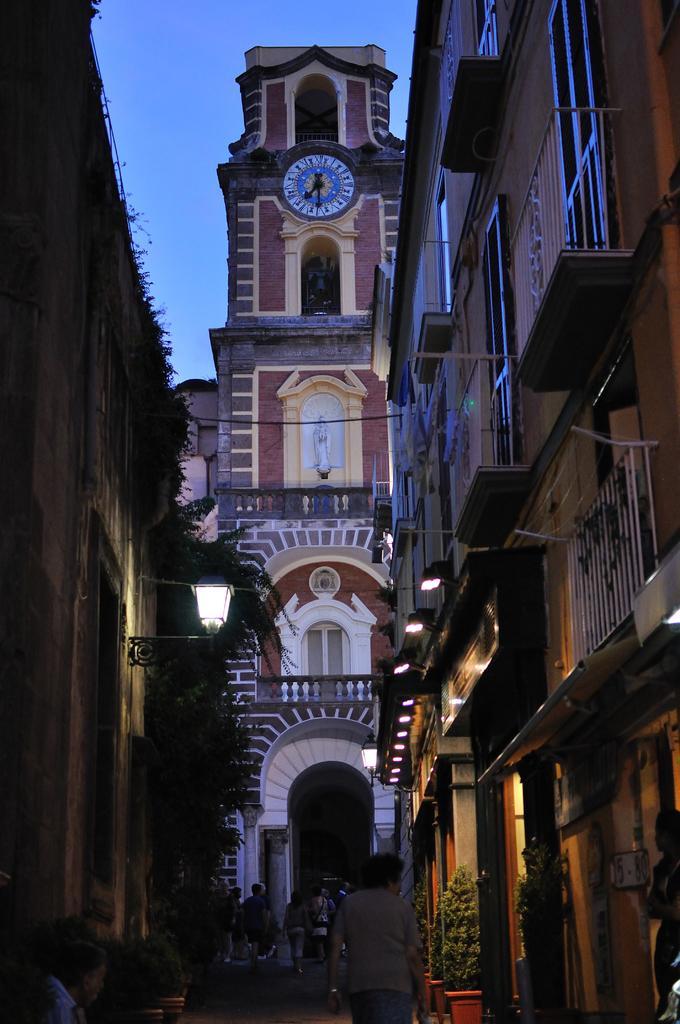Describe this image in one or two sentences. At the bottom of the picture, we see people are walking on the road. On either side of the picture, we see buildings, street lights and flower pots. In the background, we see a building or a clock tower. At the top, we see the sky, which is blue in color. 